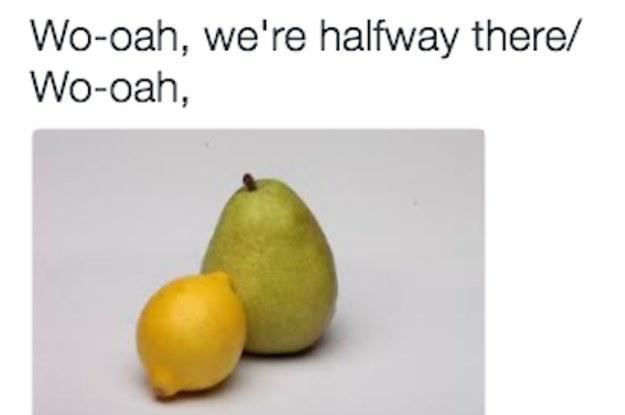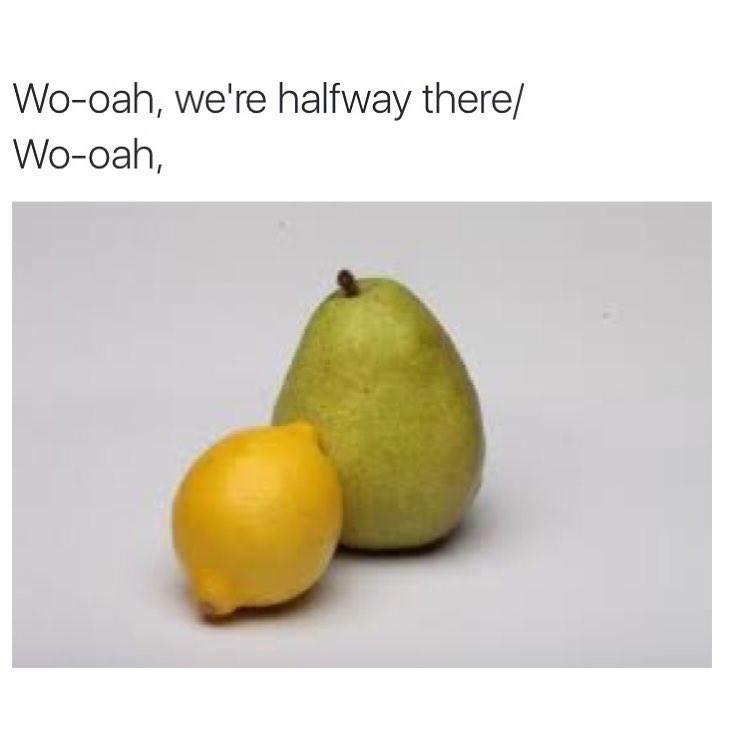The first image is the image on the left, the second image is the image on the right. Examine the images to the left and right. Is the description "In both images a lemon is in front of a pear." accurate? Answer yes or no. Yes. 